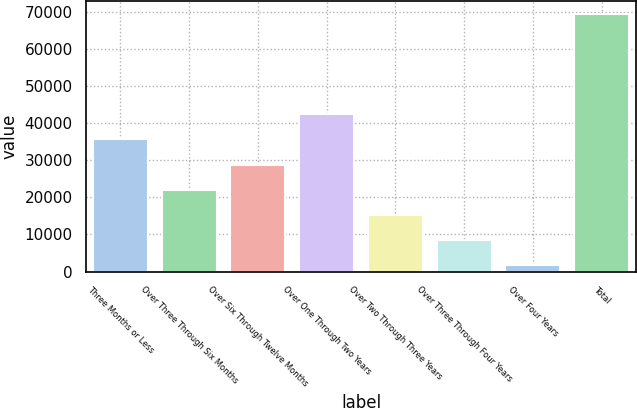<chart> <loc_0><loc_0><loc_500><loc_500><bar_chart><fcel>Three Months or Less<fcel>Over Three Through Six Months<fcel>Over Six Through Twelve Months<fcel>Over One Through Two Years<fcel>Over Two Through Three Years<fcel>Over Three Through Four Years<fcel>Over Four Years<fcel>Total<nl><fcel>35635<fcel>22101.8<fcel>28868.4<fcel>42401.6<fcel>15335.2<fcel>8568.6<fcel>1802<fcel>69468<nl></chart> 